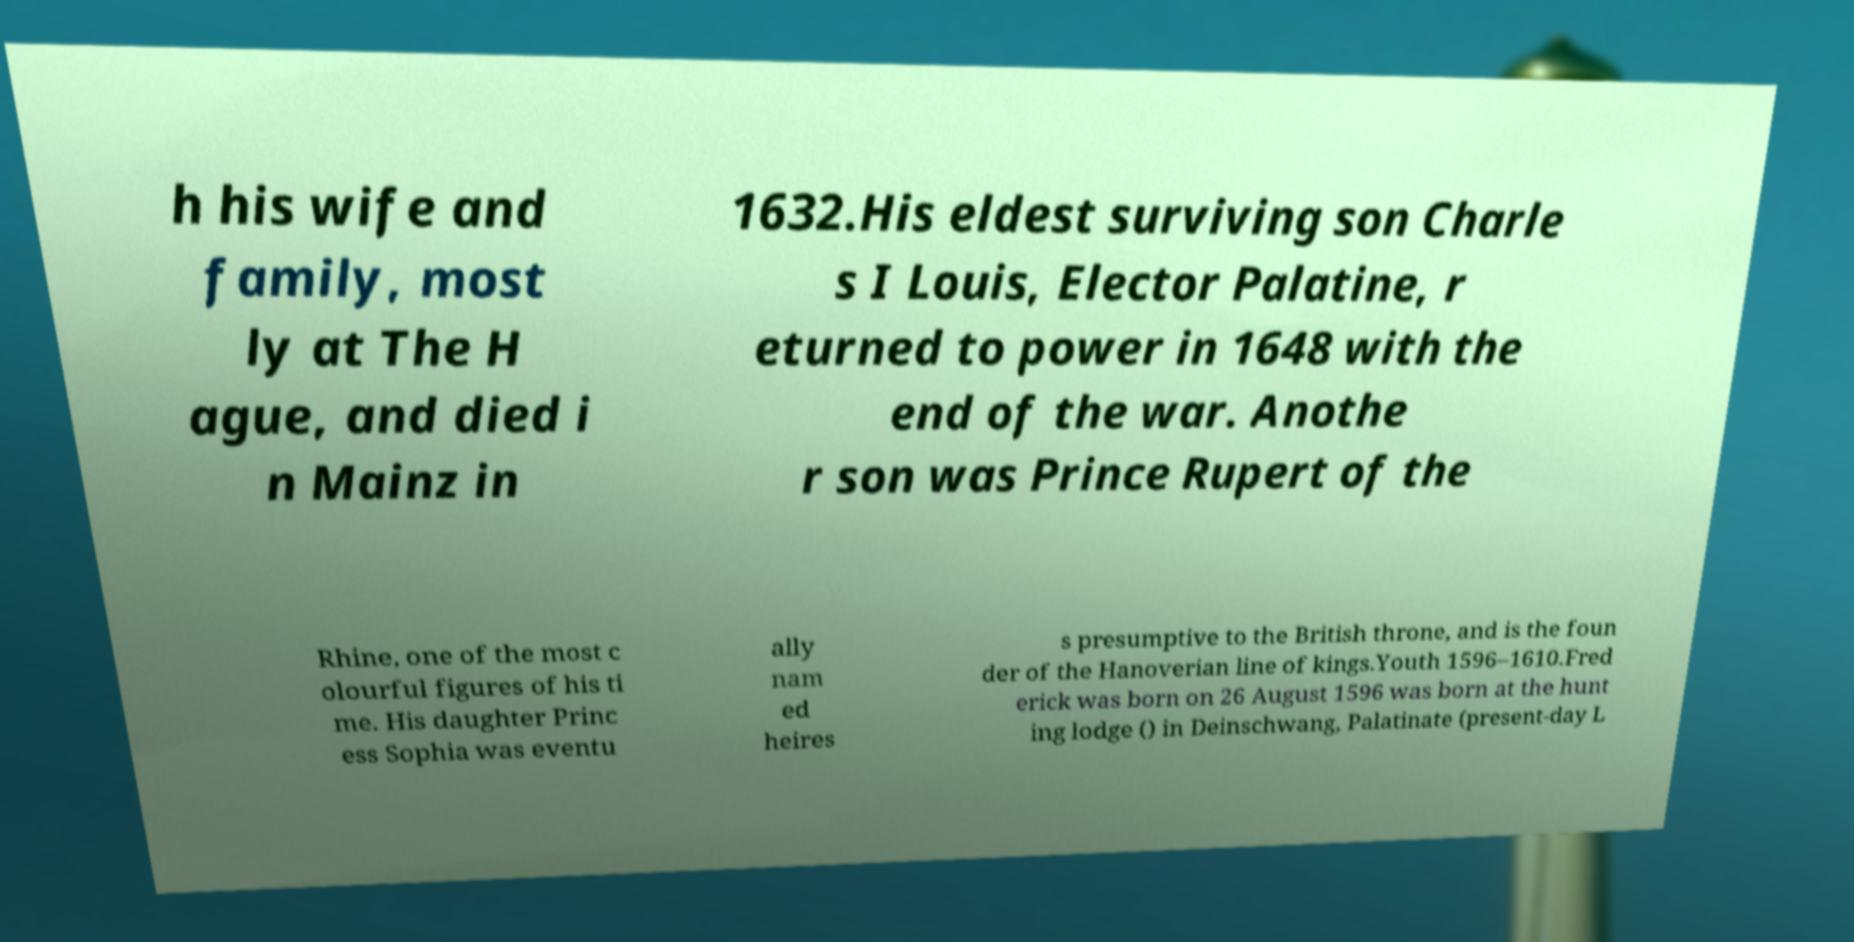Could you assist in decoding the text presented in this image and type it out clearly? h his wife and family, most ly at The H ague, and died i n Mainz in 1632.His eldest surviving son Charle s I Louis, Elector Palatine, r eturned to power in 1648 with the end of the war. Anothe r son was Prince Rupert of the Rhine, one of the most c olourful figures of his ti me. His daughter Princ ess Sophia was eventu ally nam ed heires s presumptive to the British throne, and is the foun der of the Hanoverian line of kings.Youth 1596–1610.Fred erick was born on 26 August 1596 was born at the hunt ing lodge () in Deinschwang, Palatinate (present-day L 